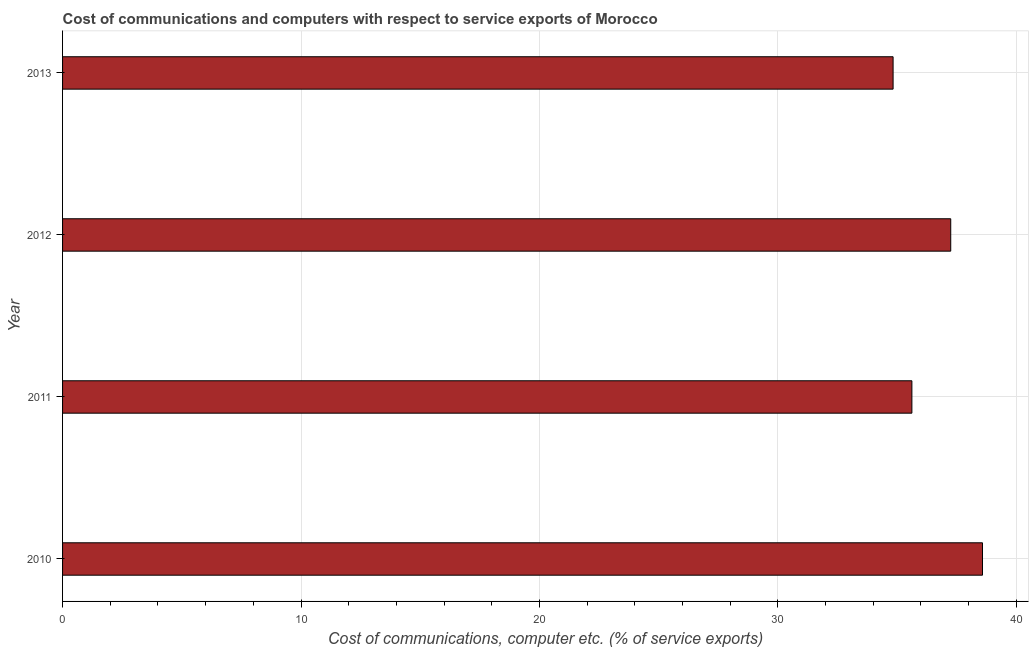Does the graph contain any zero values?
Your response must be concise. No. What is the title of the graph?
Your answer should be very brief. Cost of communications and computers with respect to service exports of Morocco. What is the label or title of the X-axis?
Your answer should be very brief. Cost of communications, computer etc. (% of service exports). What is the cost of communications and computer in 2011?
Give a very brief answer. 35.62. Across all years, what is the maximum cost of communications and computer?
Provide a short and direct response. 38.58. Across all years, what is the minimum cost of communications and computer?
Provide a succinct answer. 34.83. In which year was the cost of communications and computer maximum?
Your response must be concise. 2010. What is the sum of the cost of communications and computer?
Your answer should be compact. 146.28. What is the difference between the cost of communications and computer in 2011 and 2013?
Your answer should be very brief. 0.79. What is the average cost of communications and computer per year?
Provide a short and direct response. 36.57. What is the median cost of communications and computer?
Provide a short and direct response. 36.44. In how many years, is the cost of communications and computer greater than 16 %?
Offer a terse response. 4. Do a majority of the years between 2010 and 2013 (inclusive) have cost of communications and computer greater than 6 %?
Your response must be concise. Yes. What is the ratio of the cost of communications and computer in 2012 to that in 2013?
Offer a very short reply. 1.07. Is the cost of communications and computer in 2011 less than that in 2012?
Keep it short and to the point. Yes. Is the difference between the cost of communications and computer in 2010 and 2011 greater than the difference between any two years?
Keep it short and to the point. No. What is the difference between the highest and the second highest cost of communications and computer?
Keep it short and to the point. 1.33. Is the sum of the cost of communications and computer in 2011 and 2013 greater than the maximum cost of communications and computer across all years?
Your answer should be very brief. Yes. What is the difference between the highest and the lowest cost of communications and computer?
Provide a short and direct response. 3.75. Are all the bars in the graph horizontal?
Ensure brevity in your answer.  Yes. Are the values on the major ticks of X-axis written in scientific E-notation?
Offer a terse response. No. What is the Cost of communications, computer etc. (% of service exports) in 2010?
Offer a terse response. 38.58. What is the Cost of communications, computer etc. (% of service exports) of 2011?
Ensure brevity in your answer.  35.62. What is the Cost of communications, computer etc. (% of service exports) in 2012?
Provide a short and direct response. 37.25. What is the Cost of communications, computer etc. (% of service exports) of 2013?
Keep it short and to the point. 34.83. What is the difference between the Cost of communications, computer etc. (% of service exports) in 2010 and 2011?
Offer a very short reply. 2.96. What is the difference between the Cost of communications, computer etc. (% of service exports) in 2010 and 2012?
Make the answer very short. 1.33. What is the difference between the Cost of communications, computer etc. (% of service exports) in 2010 and 2013?
Your answer should be very brief. 3.75. What is the difference between the Cost of communications, computer etc. (% of service exports) in 2011 and 2012?
Ensure brevity in your answer.  -1.63. What is the difference between the Cost of communications, computer etc. (% of service exports) in 2011 and 2013?
Ensure brevity in your answer.  0.79. What is the difference between the Cost of communications, computer etc. (% of service exports) in 2012 and 2013?
Give a very brief answer. 2.42. What is the ratio of the Cost of communications, computer etc. (% of service exports) in 2010 to that in 2011?
Your answer should be very brief. 1.08. What is the ratio of the Cost of communications, computer etc. (% of service exports) in 2010 to that in 2012?
Your answer should be compact. 1.04. What is the ratio of the Cost of communications, computer etc. (% of service exports) in 2010 to that in 2013?
Your answer should be very brief. 1.11. What is the ratio of the Cost of communications, computer etc. (% of service exports) in 2011 to that in 2012?
Make the answer very short. 0.96. What is the ratio of the Cost of communications, computer etc. (% of service exports) in 2011 to that in 2013?
Make the answer very short. 1.02. What is the ratio of the Cost of communications, computer etc. (% of service exports) in 2012 to that in 2013?
Keep it short and to the point. 1.07. 